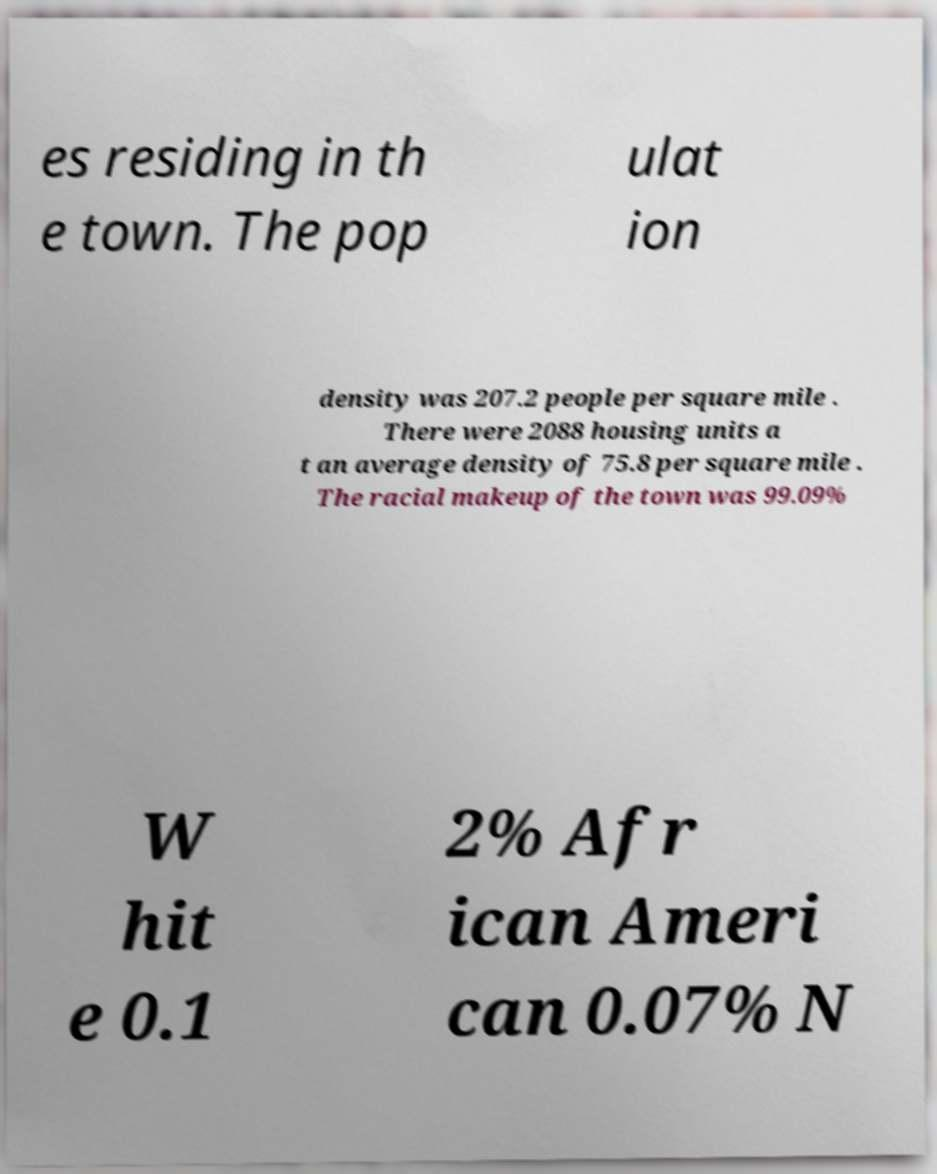Could you extract and type out the text from this image? es residing in th e town. The pop ulat ion density was 207.2 people per square mile . There were 2088 housing units a t an average density of 75.8 per square mile . The racial makeup of the town was 99.09% W hit e 0.1 2% Afr ican Ameri can 0.07% N 